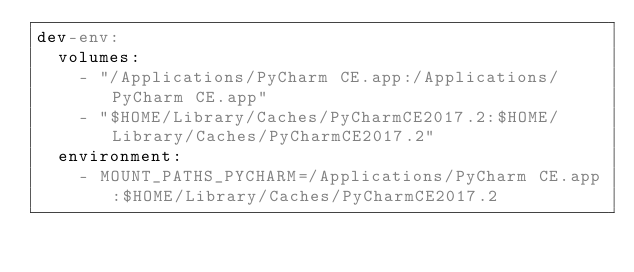Convert code to text. <code><loc_0><loc_0><loc_500><loc_500><_YAML_>dev-env:
  volumes:
    - "/Applications/PyCharm CE.app:/Applications/PyCharm CE.app"
    - "$HOME/Library/Caches/PyCharmCE2017.2:$HOME/Library/Caches/PyCharmCE2017.2"
  environment:
    - MOUNT_PATHS_PYCHARM=/Applications/PyCharm CE.app:$HOME/Library/Caches/PyCharmCE2017.2</code> 